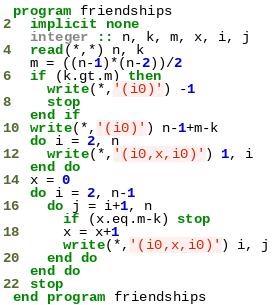Convert code to text. <code><loc_0><loc_0><loc_500><loc_500><_FORTRAN_>program friendships
  implicit none
  integer :: n, k, m, x, i, j
  read(*,*) n, k
  m = ((n-1)*(n-2))/2
  if (k.gt.m) then
    write(*,'(i0)') -1
    stop
  end if
  write(*,'(i0)') n-1+m-k
  do i = 2, n
    write(*,'(i0,x,i0)') 1, i
  end do
  x = 0
  do i = 2, n-1
    do j = i+1, n
      if (x.eq.m-k) stop
      x = x+1
      write(*,'(i0,x,i0)') i, j
    end do
  end do
  stop
end program friendships</code> 